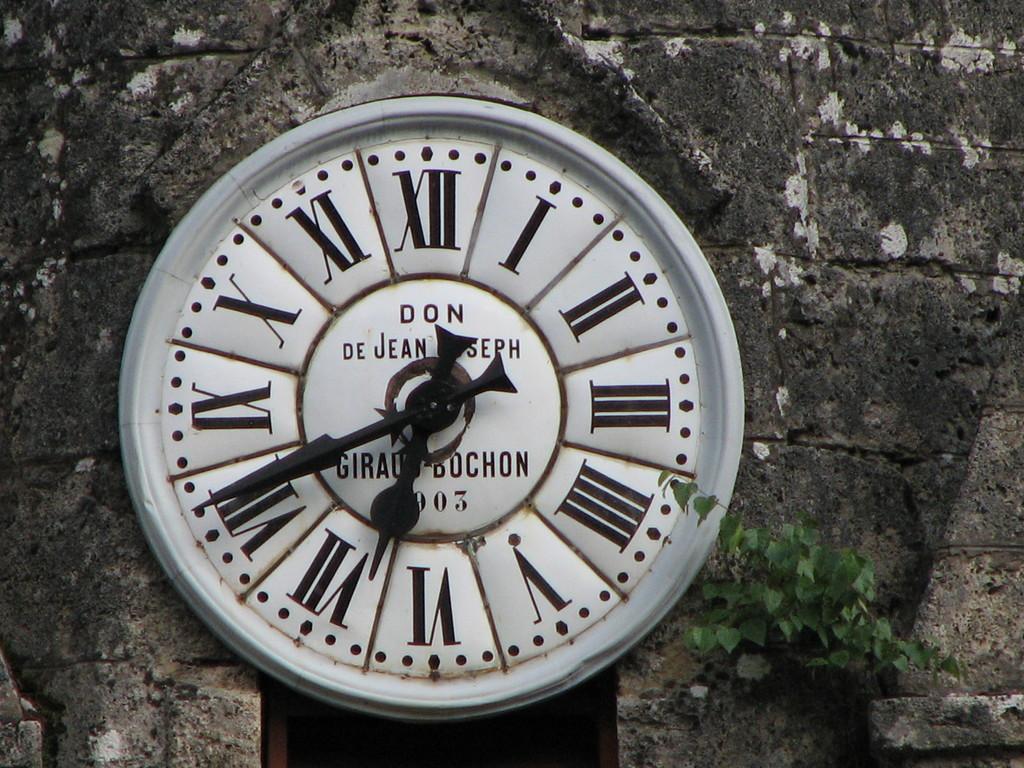What time is it?
Ensure brevity in your answer.  6:41. What roman numeral is the big hand on?
Offer a terse response. Viii. 